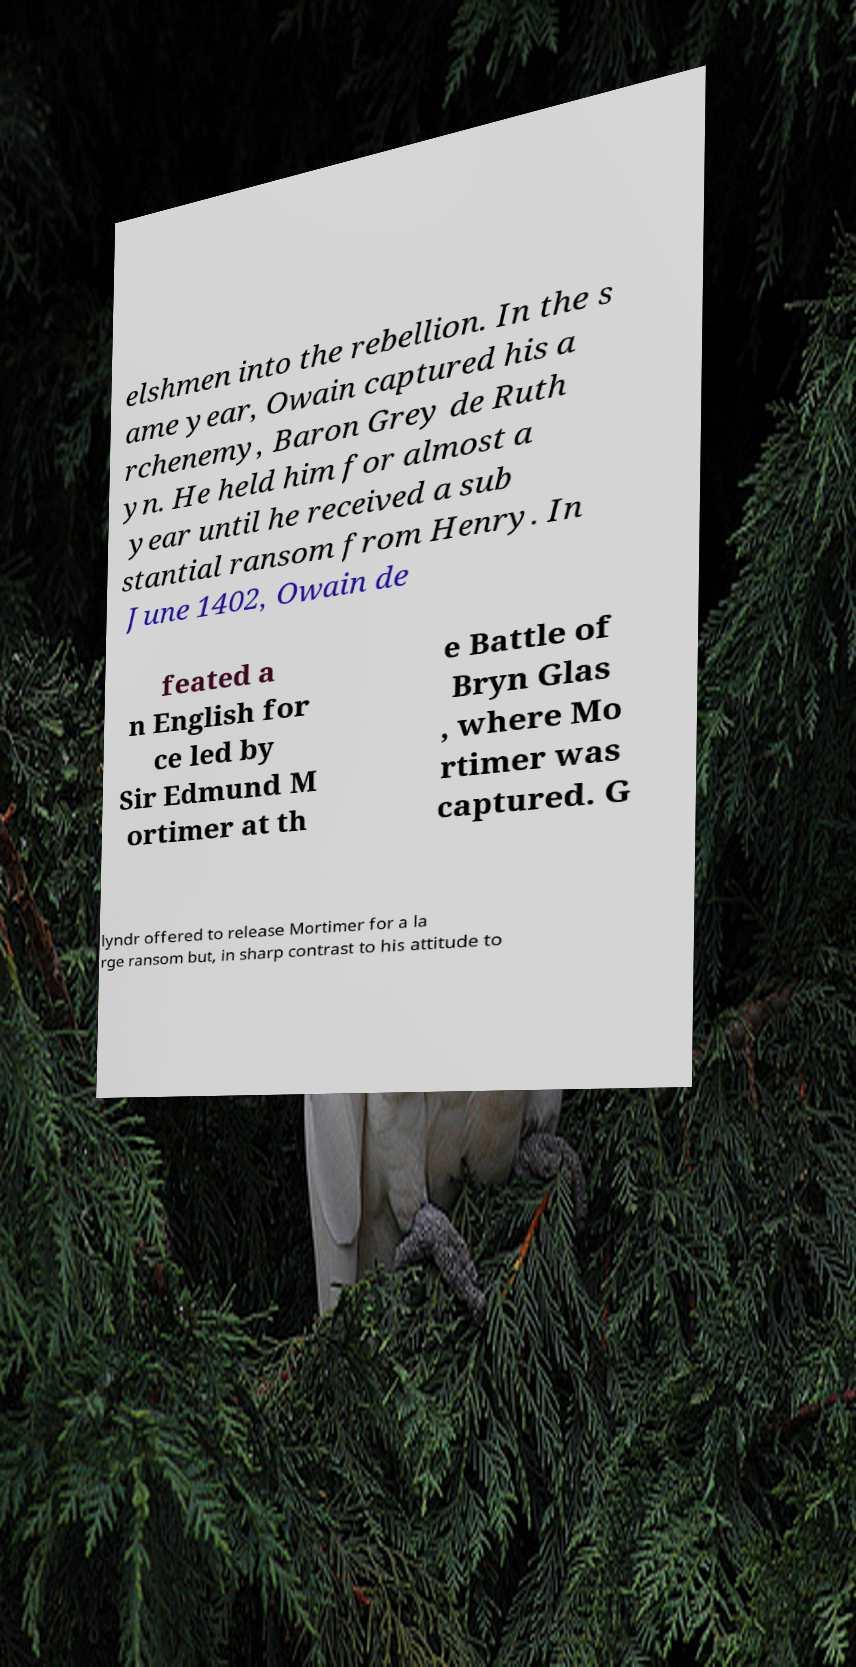There's text embedded in this image that I need extracted. Can you transcribe it verbatim? elshmen into the rebellion. In the s ame year, Owain captured his a rchenemy, Baron Grey de Ruth yn. He held him for almost a year until he received a sub stantial ransom from Henry. In June 1402, Owain de feated a n English for ce led by Sir Edmund M ortimer at th e Battle of Bryn Glas , where Mo rtimer was captured. G lyndr offered to release Mortimer for a la rge ransom but, in sharp contrast to his attitude to 